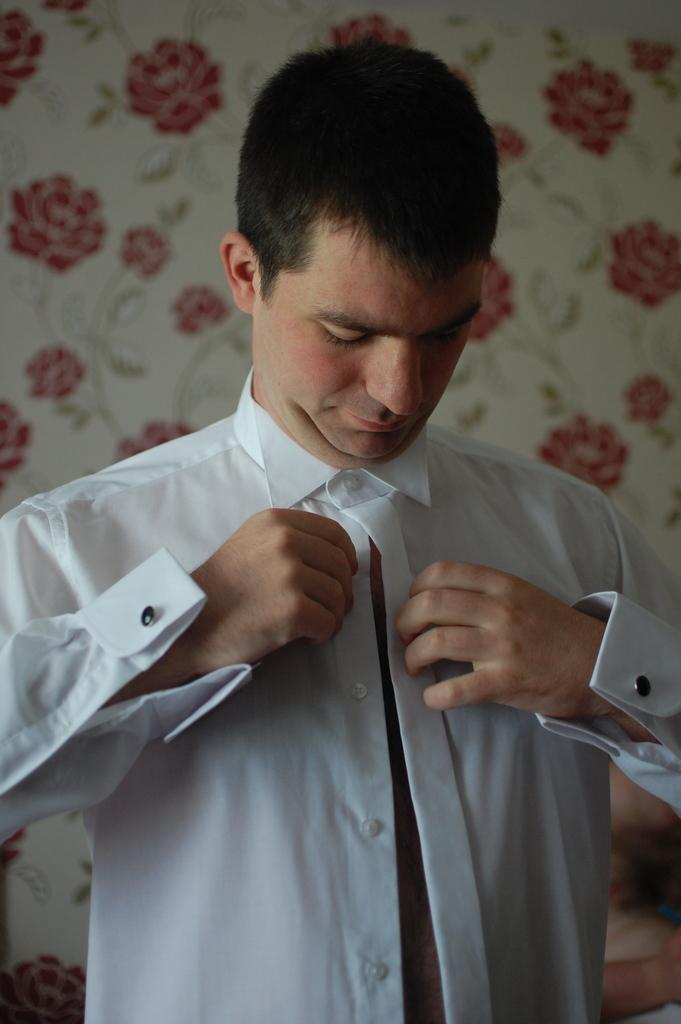Who is present in the image? There is a man in the image. What is the man wearing? The man is wearing a white shirt. What can be seen in the background of the image? There is a wall in the background of the image. What type of design is on the wall? The wall has designs of flowers. Can you see any agreements being signed in the image? There is no indication of any agreements being signed in the image. Are there any bees buzzing around the flowers on the wall in the image? There is no mention of bees or any other insects in the image; it only features a man, a white shirt, and a wall with flower designs. 